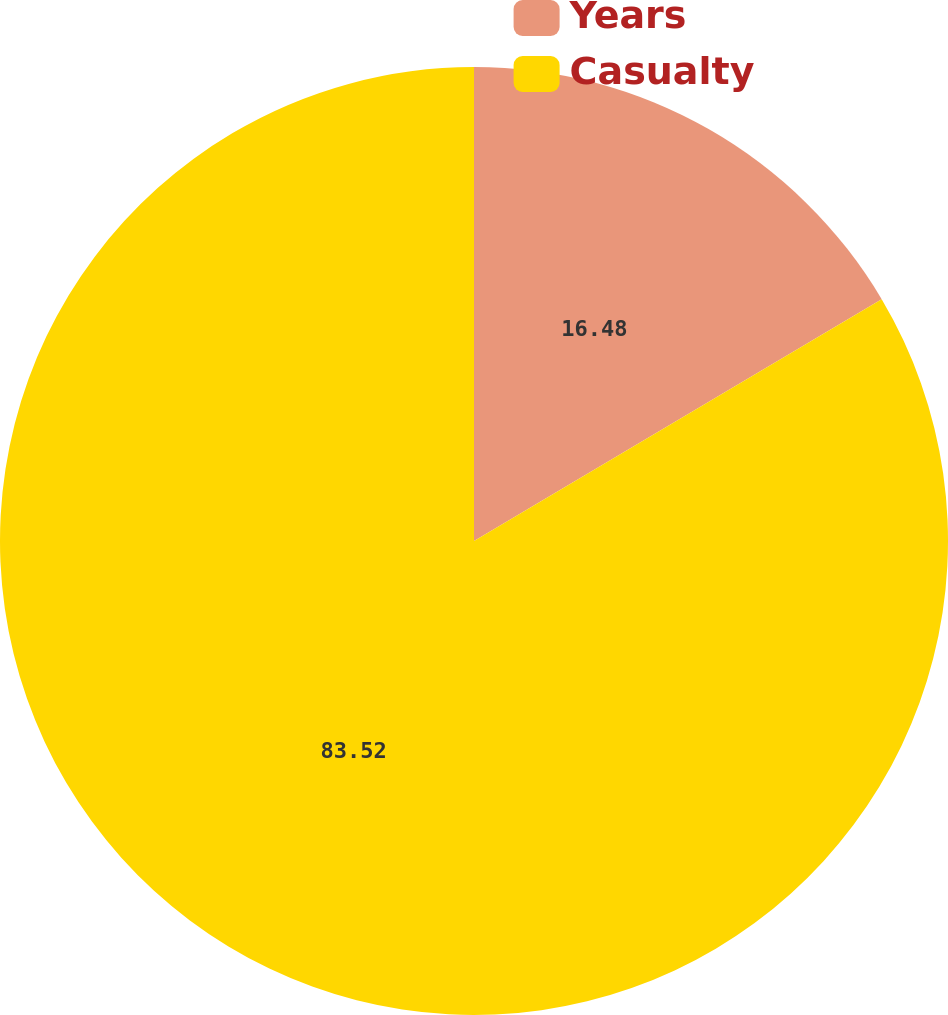Convert chart to OTSL. <chart><loc_0><loc_0><loc_500><loc_500><pie_chart><fcel>Years<fcel>Casualty<nl><fcel>16.48%<fcel>83.52%<nl></chart> 